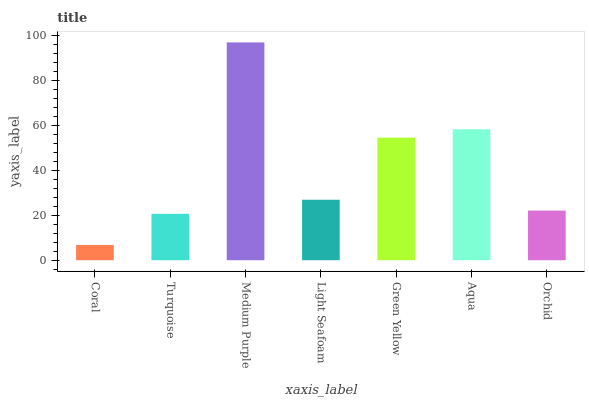Is Coral the minimum?
Answer yes or no. Yes. Is Medium Purple the maximum?
Answer yes or no. Yes. Is Turquoise the minimum?
Answer yes or no. No. Is Turquoise the maximum?
Answer yes or no. No. Is Turquoise greater than Coral?
Answer yes or no. Yes. Is Coral less than Turquoise?
Answer yes or no. Yes. Is Coral greater than Turquoise?
Answer yes or no. No. Is Turquoise less than Coral?
Answer yes or no. No. Is Light Seafoam the high median?
Answer yes or no. Yes. Is Light Seafoam the low median?
Answer yes or no. Yes. Is Aqua the high median?
Answer yes or no. No. Is Green Yellow the low median?
Answer yes or no. No. 